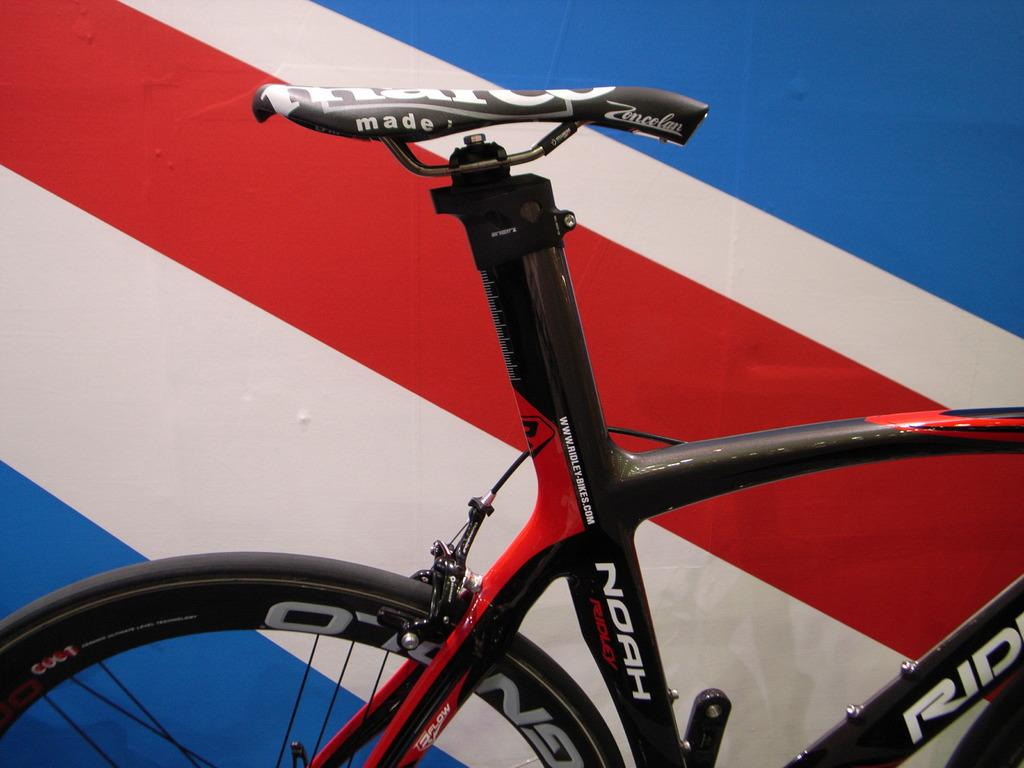What part of a bicycle can be seen in the image? A bicycle wheel, a bicycle tyre, and a bicycle seat can be seen in the image. What other components are present in the image? There are rods and wire visible in the image. What can be observed in the background of the image? The background of the image includes blue, white, and red cross lines. Can you tell me how many mines are hidden beneath the bicycle in the image? There are no mines present in the image; it features a bicycle and its components, as well as rods and wire. Is there a cave visible in the background of the image? There is no cave present in the image; the background features blue, white, and red cross lines. 